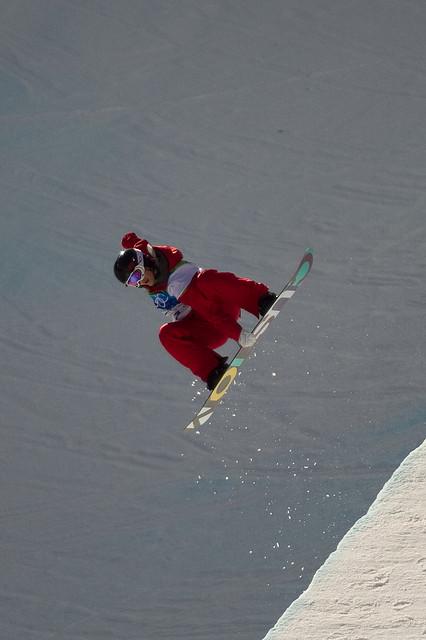Is this person snowboarding?
Concise answer only. Yes. Are they at the beach?
Keep it brief. No. Is this person on flat ground?
Be succinct. No. Is the border wearing head protection?
Concise answer only. Yes. Are the snowboarder's goggles over his eyes?
Concise answer only. Yes. 